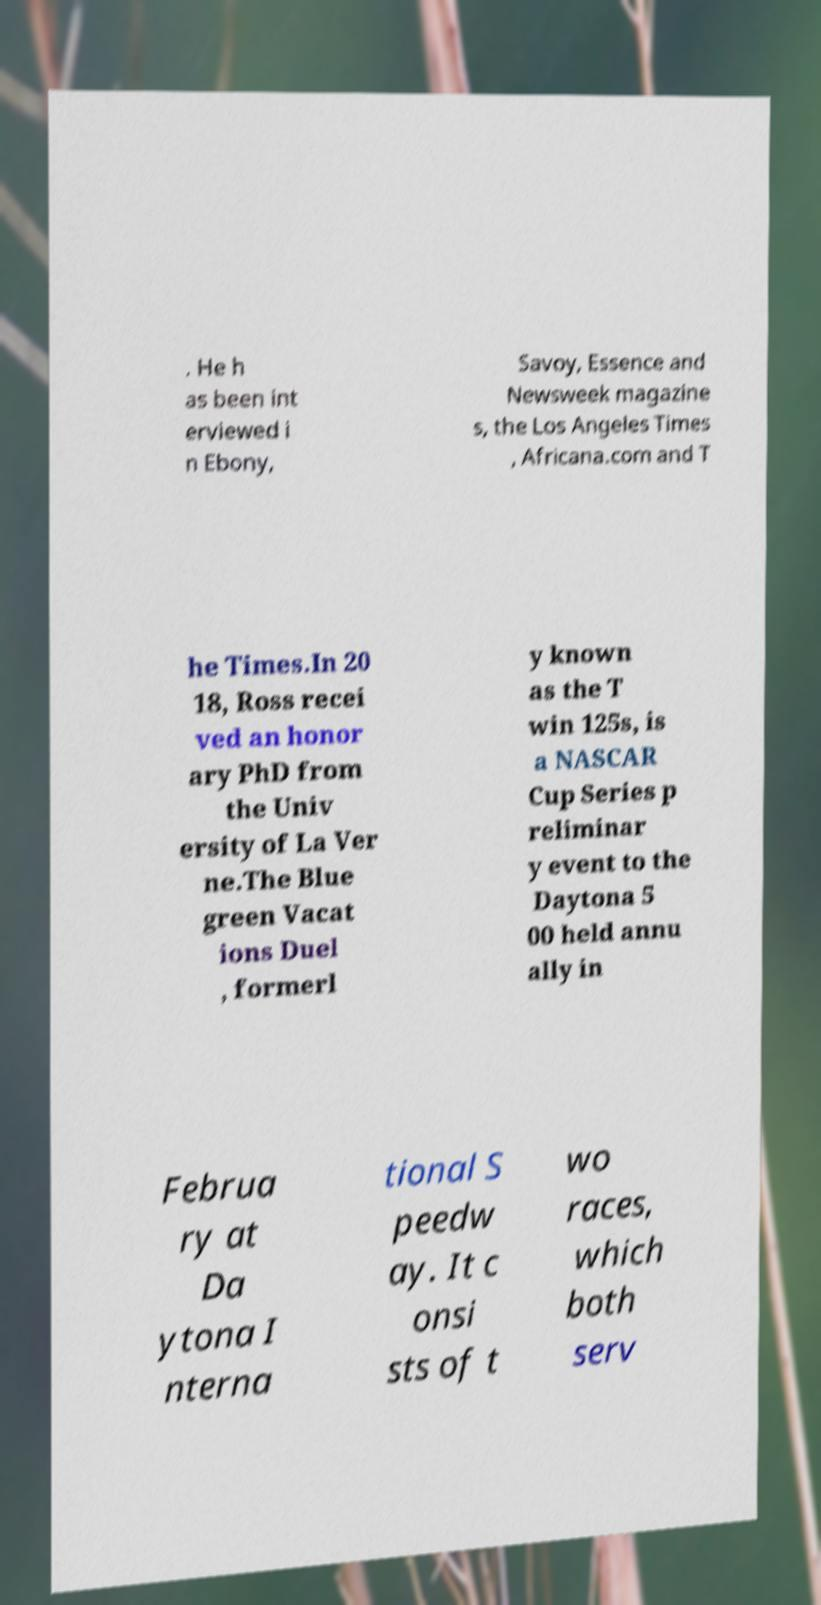Can you accurately transcribe the text from the provided image for me? . He h as been int erviewed i n Ebony, Savoy, Essence and Newsweek magazine s, the Los Angeles Times , Africana.com and T he Times.In 20 18, Ross recei ved an honor ary PhD from the Univ ersity of La Ver ne.The Blue green Vacat ions Duel , formerl y known as the T win 125s, is a NASCAR Cup Series p reliminar y event to the Daytona 5 00 held annu ally in Februa ry at Da ytona I nterna tional S peedw ay. It c onsi sts of t wo races, which both serv 